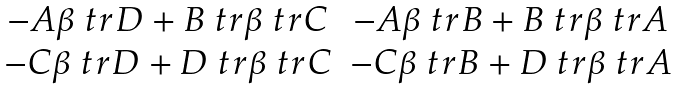<formula> <loc_0><loc_0><loc_500><loc_500>\begin{matrix} - A \beta \ t r D + B \ t r { \beta } \ t r C & - A \beta \ t r B + B \ t r { \beta } \ t r A \\ - C \beta \ t r D + D \ t r { \beta } \ t r C & - C \beta \ t r B + D \ t r { \beta } \ t r A \end{matrix}</formula> 